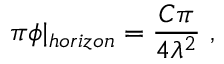<formula> <loc_0><loc_0><loc_500><loc_500>\pi \phi | _ { h o r i z o n } = \frac { C \pi } { 4 \lambda ^ { 2 } } \ ,</formula> 